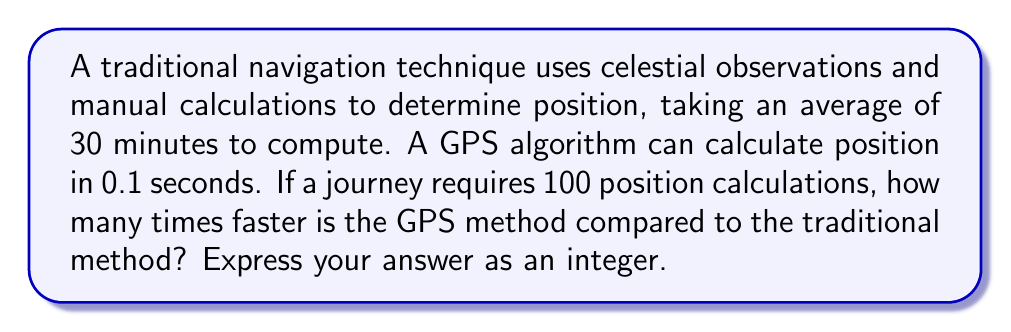Can you answer this question? To solve this problem, we need to follow these steps:

1. Calculate the total time for traditional navigation:
   - Time per calculation: 30 minutes
   - Number of calculations: 100
   - Total time = $30 \times 100 = 3000$ minutes

2. Calculate the total time for GPS navigation:
   - Time per calculation: 0.1 seconds
   - Number of calculations: 100
   - Total time = $0.1 \times 100 = 10$ seconds

3. Convert both times to the same unit (seconds):
   - Traditional: $3000 \text{ minutes} = 3000 \times 60 = 180000 \text{ seconds}$
   - GPS: 10 seconds (already in seconds)

4. Calculate the speed ratio:
   $$ \text{Speed ratio} = \frac{\text{Traditional time}}{\text{GPS time}} = \frac{180000}{10} = 18000 $$

Therefore, the GPS method is 18000 times faster than the traditional method.
Answer: 18000 